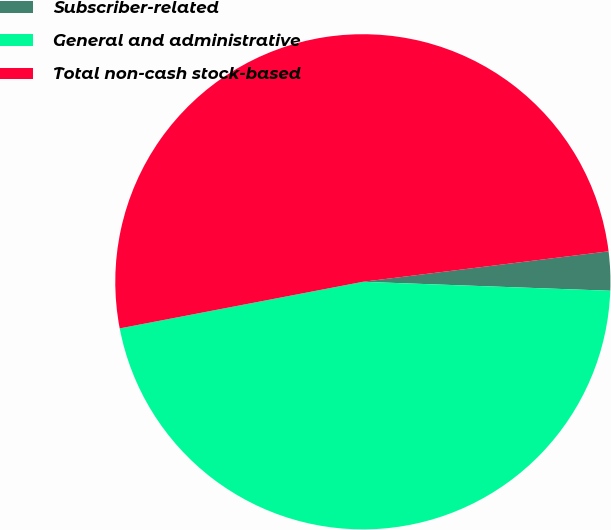<chart> <loc_0><loc_0><loc_500><loc_500><pie_chart><fcel>Subscriber-related<fcel>General and administrative<fcel>Total non-cash stock-based<nl><fcel>2.54%<fcel>46.41%<fcel>51.05%<nl></chart> 